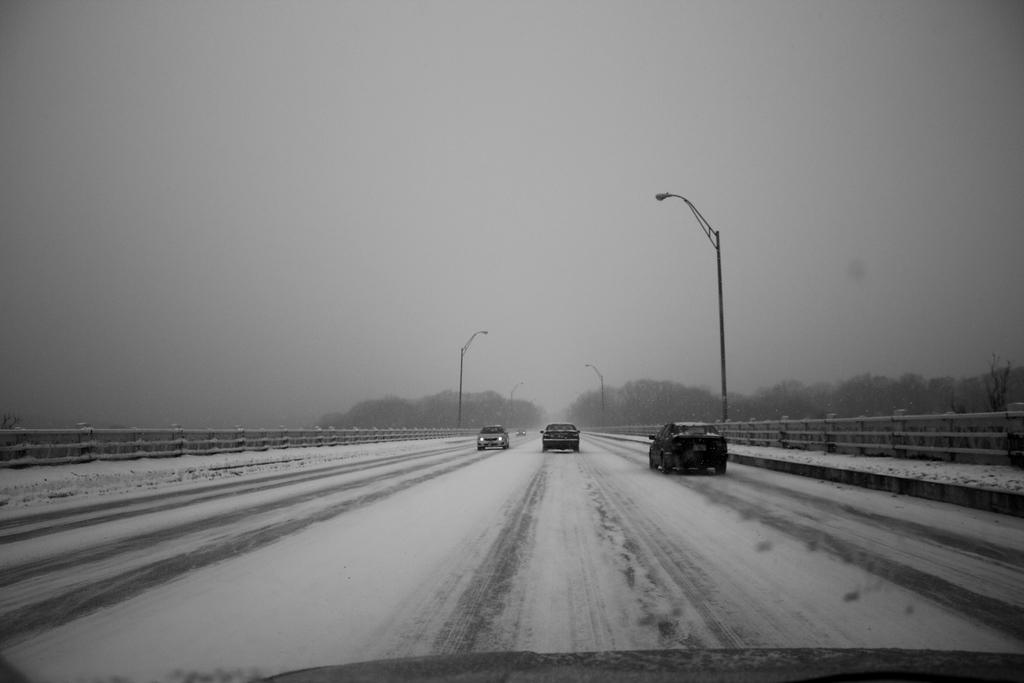What is the color scheme of the image? The image is black and white. What is happening on the road in the image? There are vehicles moving on the road in the image. What structures are present alongside the road? There are street lights on either side of the road. What can be seen in the distance in the image? There are trees visible in the background of the image. How many cherries are hanging from the trees in the image? There are no cherries visible in the image; only trees are present in the background. What type of army vehicles can be seen in the image? There are no army vehicles or any reference to an army in the image; it features vehicles moving on a road with street lights and trees in the background. 